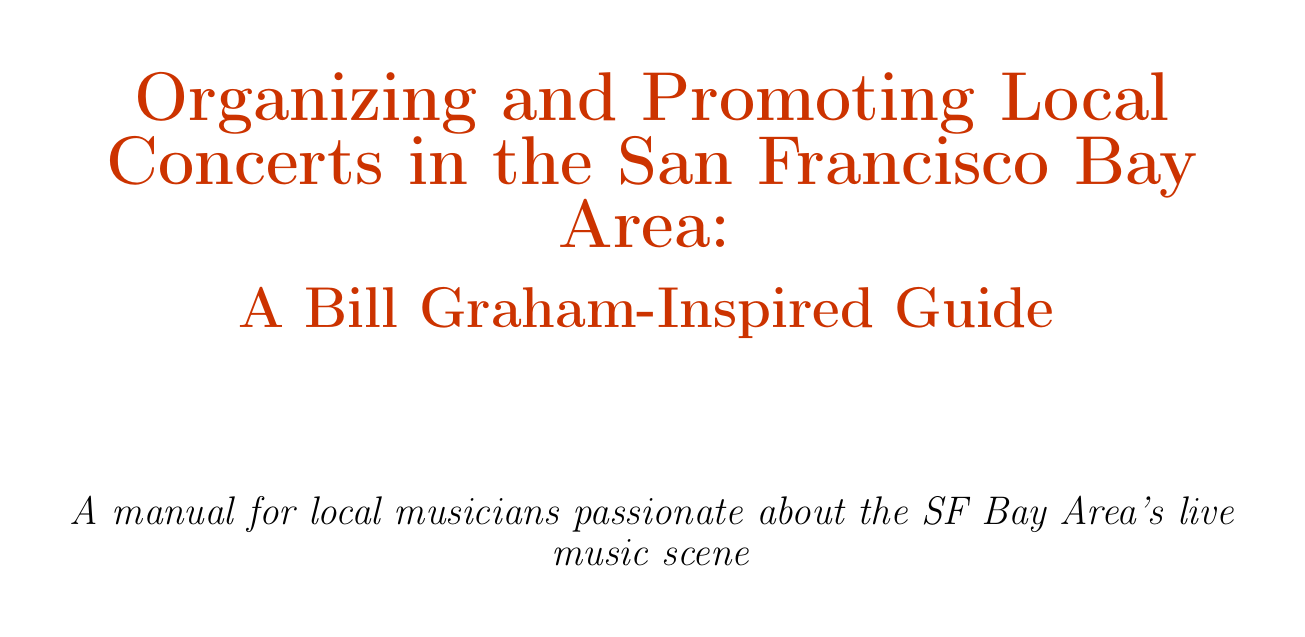What is the title of the manual? The title of the manual is stated at the beginning of the document.
Answer: Organizing and Promoting Local Concerts in the San Francisco Bay Area: A Bill Graham-Inspired Guide Who is the legendary promoter mentioned in the introduction? The introduction highlights a key figure in the music scene of the San Francisco Bay Area.
Answer: Bill Graham Which venue is suggested for a smaller audience? The document provides specific examples of venues that suit different audience sizes.
Answer: Bottom of the Hill What type of collaborations does the document suggest when curating a lineup? The chapter on curating a compelling lineup discusses possibilities for combining music genres.
Answer: Cross-genre collaborations Which local organization is mentioned for networking? The manual suggests joining professional organizations for enhancing industry relationships.
Answer: The Recording Academy San Francisco Chapter What is a suggested promotional material type in the document? The section on designing materials describes multiple forms of promotion to attract audiences.
Answer: Concert poster How should you enhance audience experience according to the document? The guide discusses unique experiences to create memorable events.
Answer: Pre-show activities What is one of the key takeaways from the manual? The conclusion summarizes important lessons from organizing and promoting concerts.
Answer: Blend traditional promotion with modern digital strategies What is the goal of the manual? This detail can be found in the introduction as the overarching intention of the document.
Answer: Empower local musicians to organize successful shows 